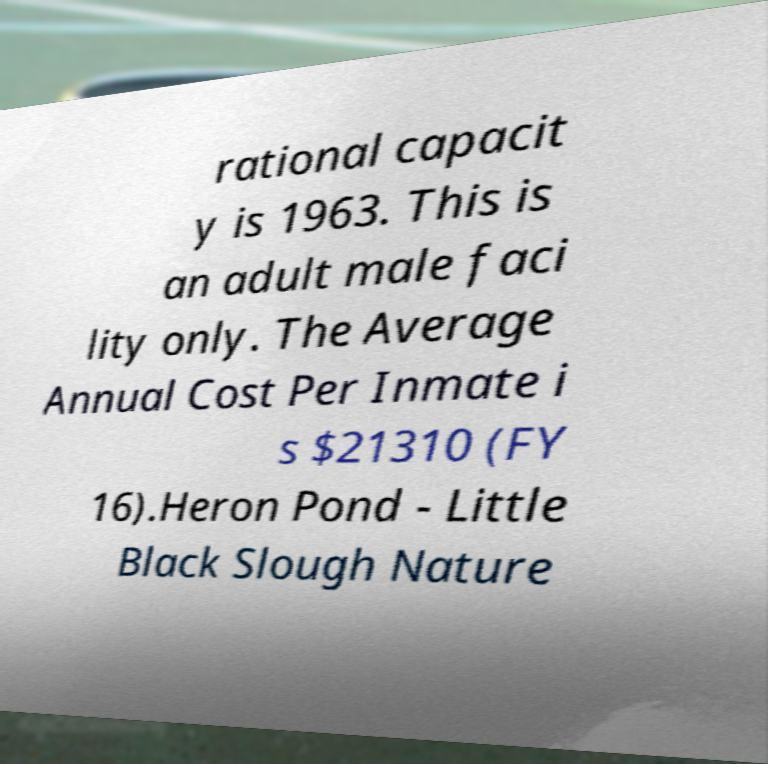There's text embedded in this image that I need extracted. Can you transcribe it verbatim? rational capacit y is 1963. This is an adult male faci lity only. The Average Annual Cost Per Inmate i s $21310 (FY 16).Heron Pond - Little Black Slough Nature 